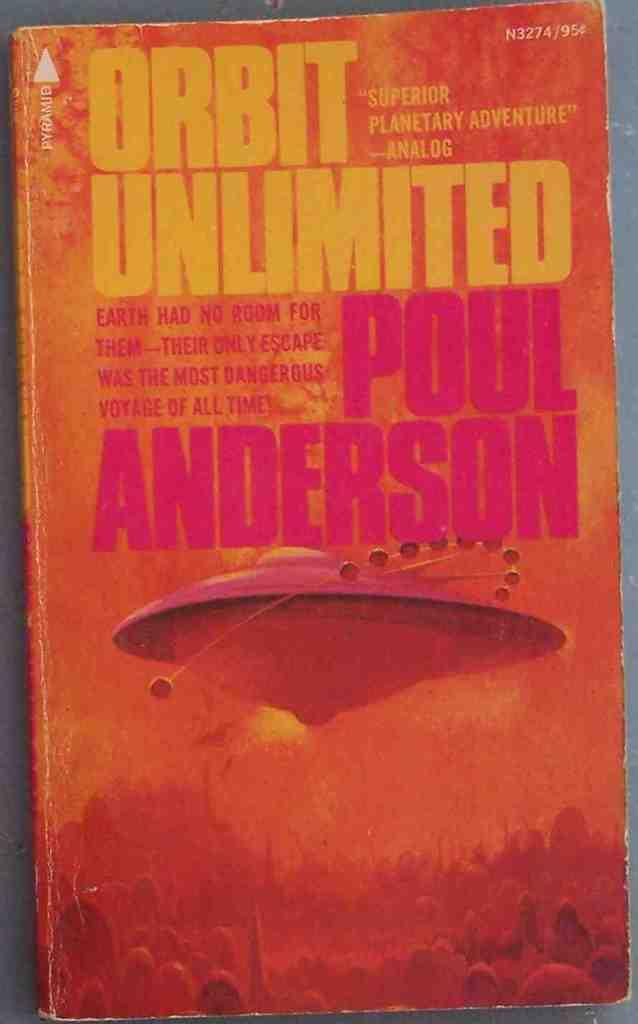<image>
Give a short and clear explanation of the subsequent image. Analog called the book ORBIT UNLIMITED a "Superior Planetary Adventure". 